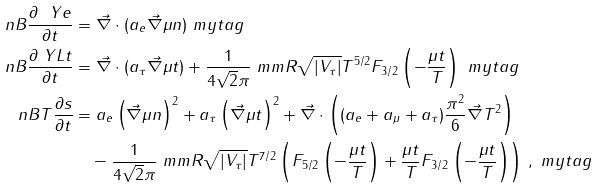<formula> <loc_0><loc_0><loc_500><loc_500>\ n B \frac { \partial \ Y e } { \partial t } & = \vec { \nabla } \cdot ( a _ { e } \vec { \nabla } \mu n ) \ m y t a g \\ \ n B \frac { \partial \ Y L t } { \partial t } & = \vec { \nabla } \cdot ( a _ { \tau } \vec { \nabla } \mu t ) + \frac { 1 } { 4 \sqrt { 2 } \pi } \ m m R \sqrt { | V _ { \tau } | } T ^ { 5 / 2 } F _ { 3 / 2 } \left ( - \frac { \mu t } { T } \right ) \ m y t a g \\ \ n B T \frac { \partial s } { \partial t } & = a _ { e } \left ( \vec { \nabla } \mu n \right ) ^ { 2 } + a _ { \tau } \left ( \vec { \nabla } \mu t \right ) ^ { 2 } + \vec { \nabla } \cdot \left ( ( a _ { e } + a _ { \mu } + a _ { \tau } ) \frac { \pi ^ { 2 } } { 6 } \vec { \nabla } T ^ { 2 } \right ) \\ & \quad - \frac { 1 } { 4 \sqrt { 2 } \pi } \ m m R \sqrt { | V _ { \tau } | } T ^ { 7 / 2 } \left ( F _ { 5 / 2 } \left ( - \frac { \mu t } { T } \right ) + \frac { \mu t } { T } F _ { 3 / 2 } \left ( - \frac { \mu t } { T } \right ) \right ) \, , \ m y t a g</formula> 